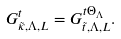<formula> <loc_0><loc_0><loc_500><loc_500>G ^ { t } _ { \tilde { \kappa } , \Lambda , L } = G ^ { t \Theta _ { \Lambda } } _ { \tilde { t } , \Lambda , L } .</formula> 